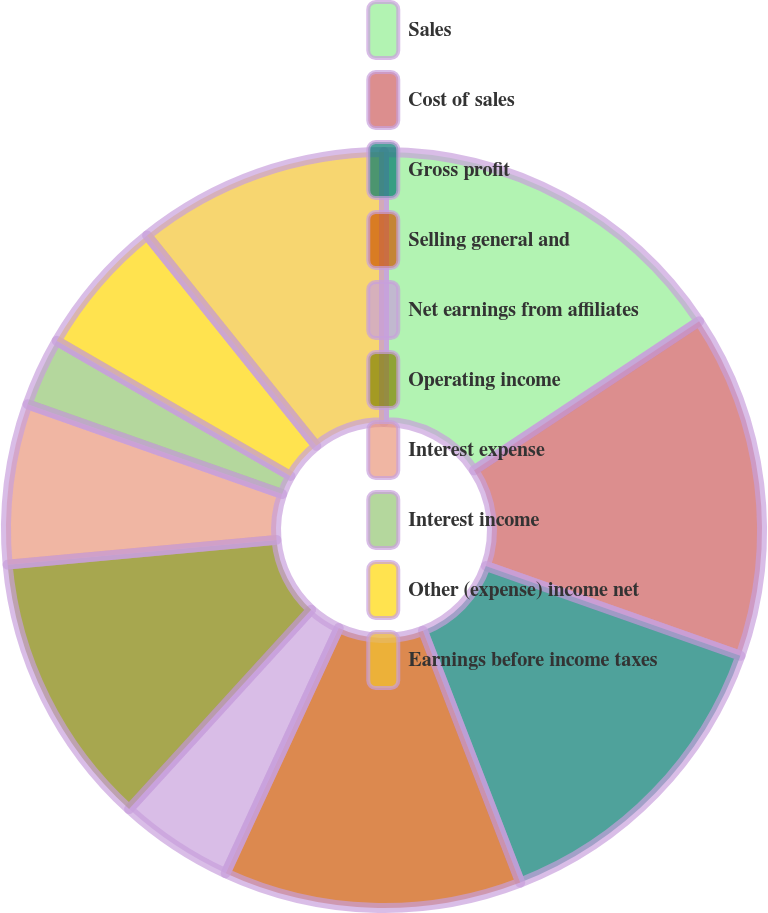<chart> <loc_0><loc_0><loc_500><loc_500><pie_chart><fcel>Sales<fcel>Cost of sales<fcel>Gross profit<fcel>Selling general and<fcel>Net earnings from affiliates<fcel>Operating income<fcel>Interest expense<fcel>Interest income<fcel>Other (expense) income net<fcel>Earnings before income taxes<nl><fcel>15.69%<fcel>14.71%<fcel>13.73%<fcel>12.75%<fcel>4.9%<fcel>11.76%<fcel>6.86%<fcel>2.94%<fcel>5.88%<fcel>10.78%<nl></chart> 